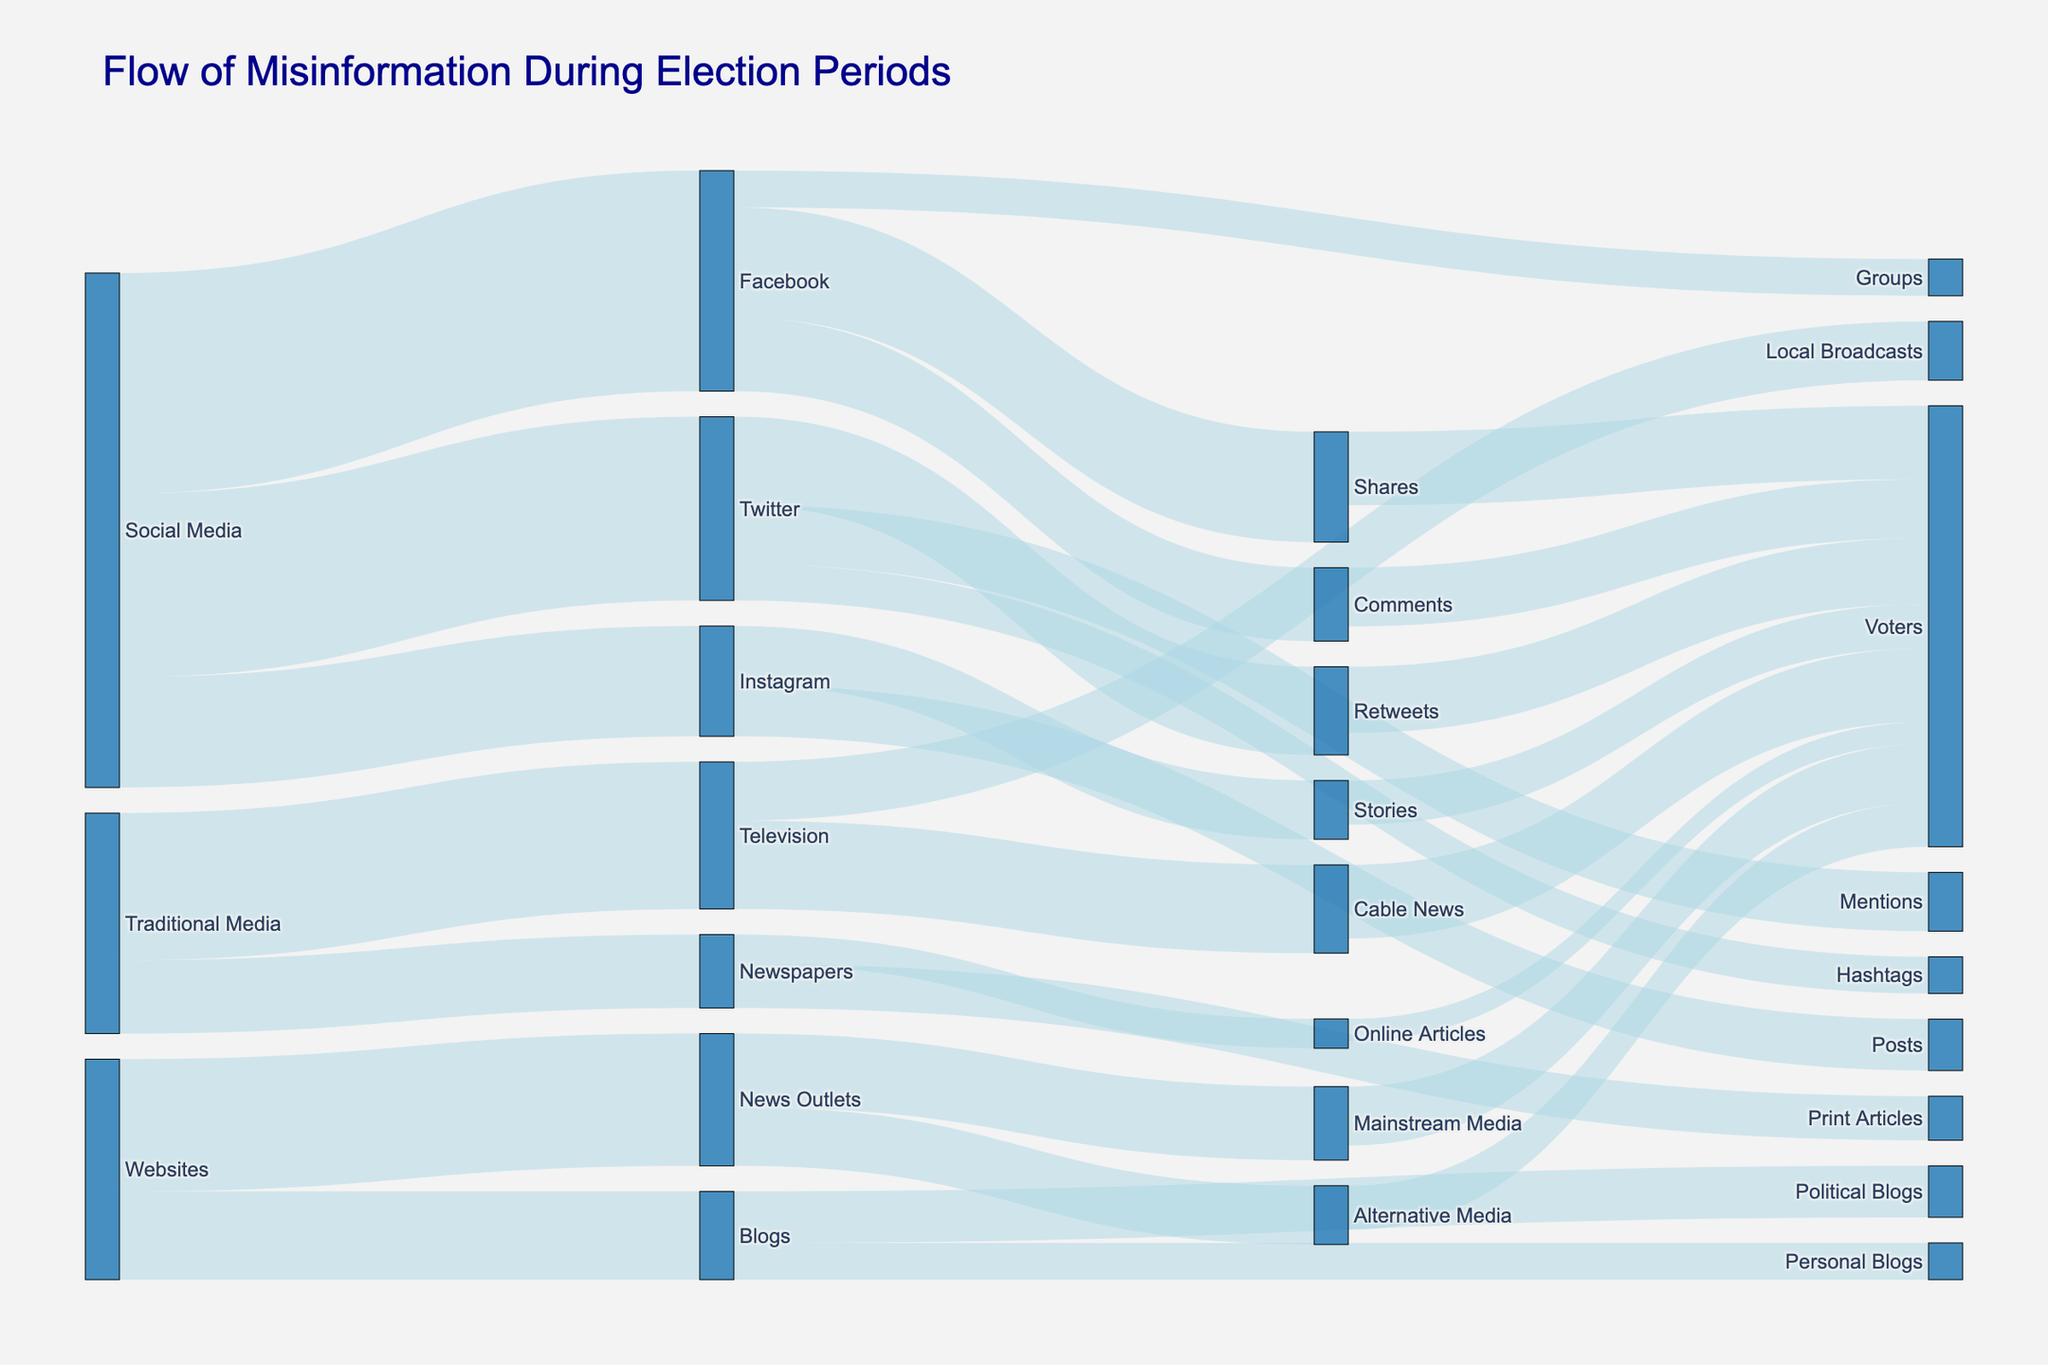What is the title of the figure? The title is located at the top of the figure, which usually describes the content or purpose of the diagram.
Answer: Flow of Misinformation During Election Periods How many channels are involved in spreading misinformation according to the diagram? Count the distinct sources in the diagram. They are Social Media, Traditional Media, and Websites.
Answer: 3 Which platform under Social Media has the highest misinformation flow? Look at the value associated with each target under Social Media. Facebook has the highest value of 3000.
Answer: Facebook What is the total misinformation distribution for Websites? Sum the values for all targets under Websites: 1800 (News Outlets) + 1200 (Blogs) = 3000.
Answer: 3000 Which type of shares or comments reaches the highest number of voters? Look at the target nodes under Facebook and count the highest value. Facebook shares reach 1000 voters.
Answer: Shares What is the combined misinformation flow through Traditional Media? Sum the values of Television (2000) and Newspapers (1000) under Traditional Media.
Answer: 3000 Are more voters reached through Television or Online Articles? Compare the voter values connected to Television (Cable News 1000) and Online Articles (300).
Answer: Television What is the total misinformation flow that directly impacts voters from Social Media platforms? Sum the values of voters connected to platforms under Social Media: Shares (1000) + Comments (800) + Retweets (900) + Stories (600) = 3300.
Answer: 3300 Through which medium does Misinformation flow to the highest number of voters, comparing Mainstream Media to Alternative Media? Look at the values directly connecting to voters: Mainstream Media (800) and Alternative Media (600).
Answer: Mainstream Media 